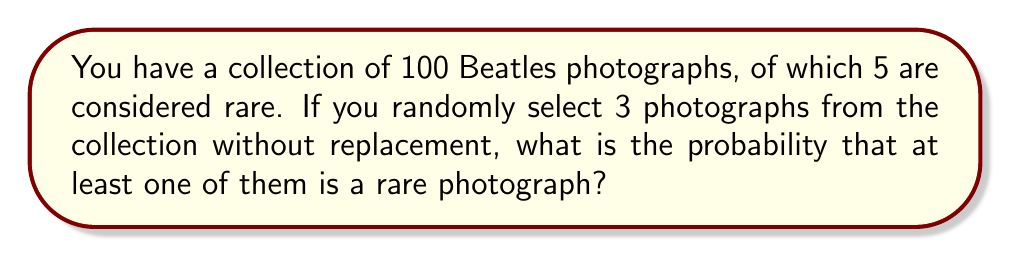Show me your answer to this math problem. Let's approach this step-by-step:

1) First, let's calculate the probability of not selecting any rare photographs. This is easier than calculating the probability of selecting at least one rare photograph directly.

2) The probability of not selecting a rare photograph on the first draw is:
   $$\frac{95}{100} = 0.95$$

3) If we didn't select a rare photograph on the first draw, the probability of not selecting a rare photograph on the second draw is:
   $$\frac{94}{99}$$

4) Similarly, for the third draw, if we didn't select a rare photograph in the first two draws, the probability is:
   $$\frac{93}{98}$$

5) The probability of not selecting any rare photographs in all three draws is the product of these probabilities:
   $$P(\text{no rare}) = \frac{95}{100} \cdot \frac{94}{99} \cdot \frac{93}{98} = 0.8570$$

6) Therefore, the probability of selecting at least one rare photograph is the complement of this probability:
   $$P(\text{at least one rare}) = 1 - P(\text{no rare}) = 1 - 0.8570 = 0.1430$$

7) We can express this as a percentage: 14.30%
Answer: 0.1430 or 14.30% 